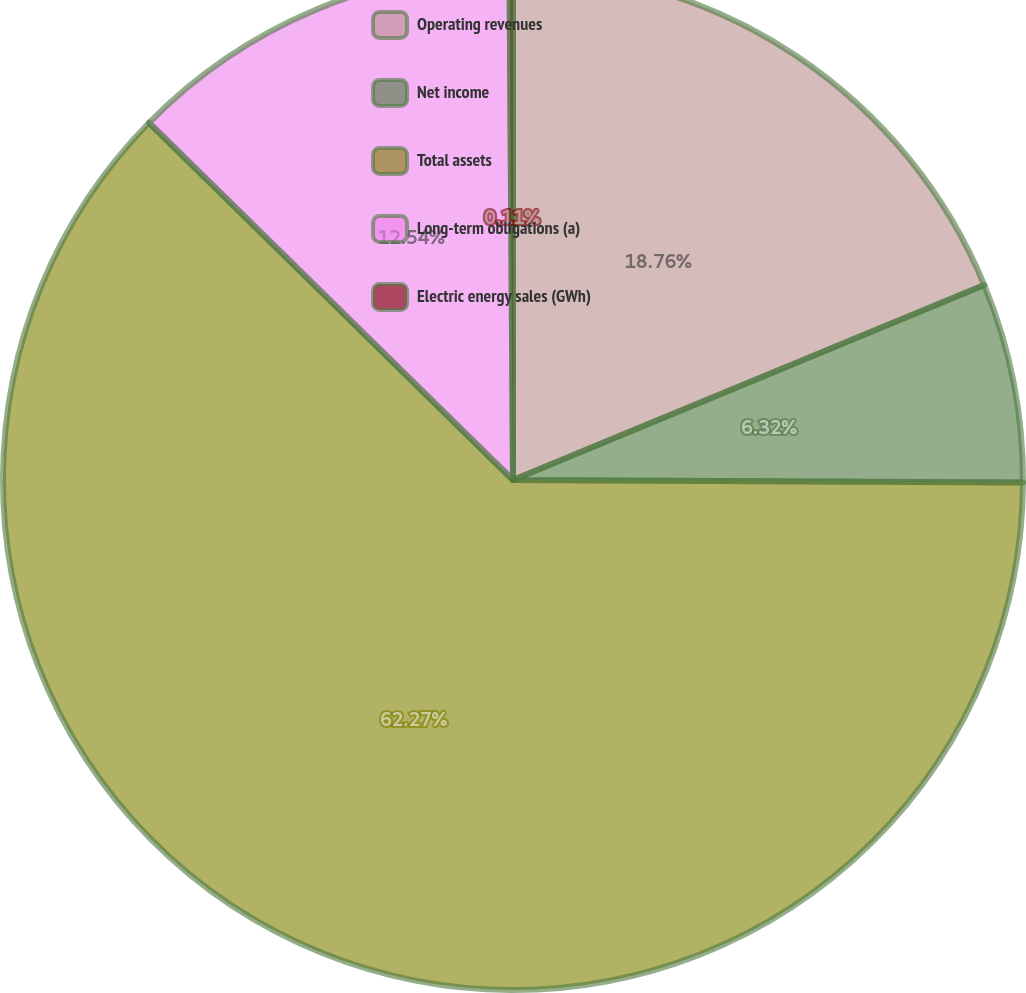Convert chart. <chart><loc_0><loc_0><loc_500><loc_500><pie_chart><fcel>Operating revenues<fcel>Net income<fcel>Total assets<fcel>Long-term obligations (a)<fcel>Electric energy sales (GWh)<nl><fcel>18.76%<fcel>6.32%<fcel>62.28%<fcel>12.54%<fcel>0.11%<nl></chart> 